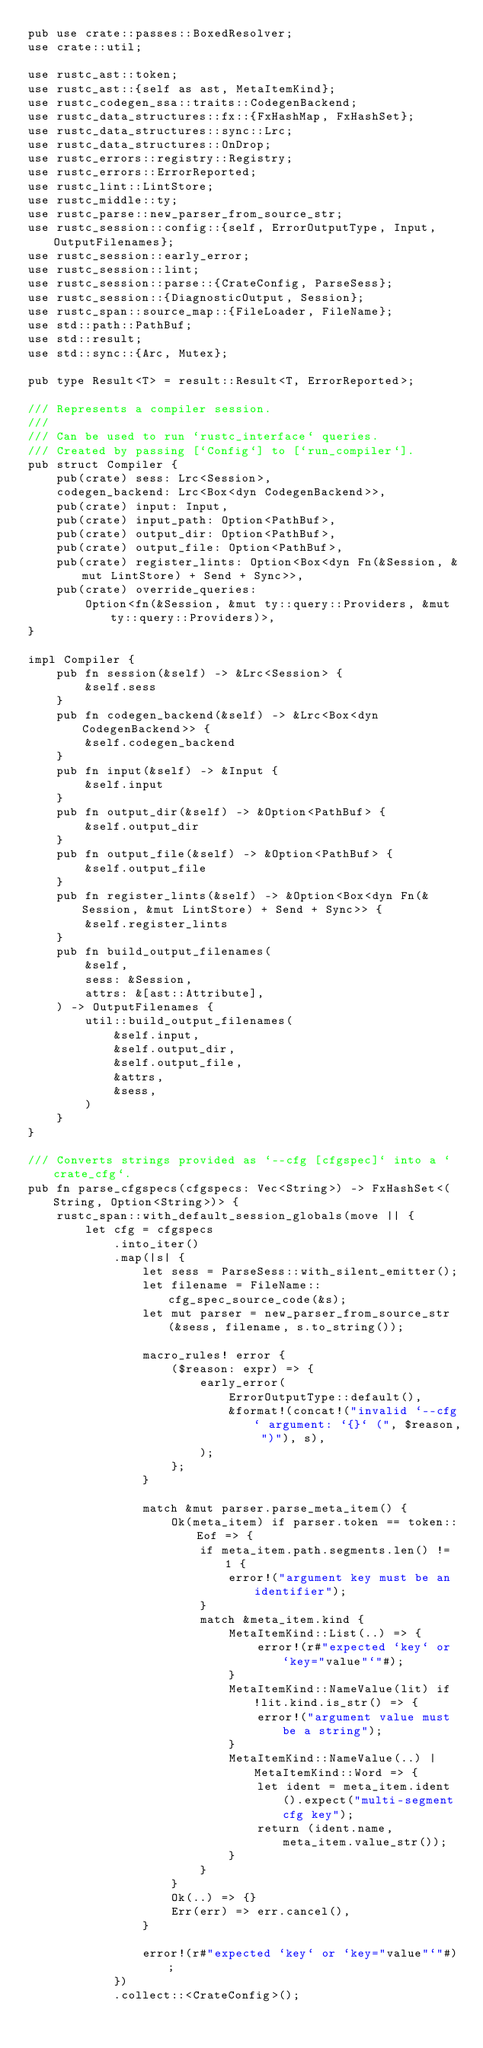Convert code to text. <code><loc_0><loc_0><loc_500><loc_500><_Rust_>pub use crate::passes::BoxedResolver;
use crate::util;

use rustc_ast::token;
use rustc_ast::{self as ast, MetaItemKind};
use rustc_codegen_ssa::traits::CodegenBackend;
use rustc_data_structures::fx::{FxHashMap, FxHashSet};
use rustc_data_structures::sync::Lrc;
use rustc_data_structures::OnDrop;
use rustc_errors::registry::Registry;
use rustc_errors::ErrorReported;
use rustc_lint::LintStore;
use rustc_middle::ty;
use rustc_parse::new_parser_from_source_str;
use rustc_session::config::{self, ErrorOutputType, Input, OutputFilenames};
use rustc_session::early_error;
use rustc_session::lint;
use rustc_session::parse::{CrateConfig, ParseSess};
use rustc_session::{DiagnosticOutput, Session};
use rustc_span::source_map::{FileLoader, FileName};
use std::path::PathBuf;
use std::result;
use std::sync::{Arc, Mutex};

pub type Result<T> = result::Result<T, ErrorReported>;

/// Represents a compiler session.
///
/// Can be used to run `rustc_interface` queries.
/// Created by passing [`Config`] to [`run_compiler`].
pub struct Compiler {
    pub(crate) sess: Lrc<Session>,
    codegen_backend: Lrc<Box<dyn CodegenBackend>>,
    pub(crate) input: Input,
    pub(crate) input_path: Option<PathBuf>,
    pub(crate) output_dir: Option<PathBuf>,
    pub(crate) output_file: Option<PathBuf>,
    pub(crate) register_lints: Option<Box<dyn Fn(&Session, &mut LintStore) + Send + Sync>>,
    pub(crate) override_queries:
        Option<fn(&Session, &mut ty::query::Providers, &mut ty::query::Providers)>,
}

impl Compiler {
    pub fn session(&self) -> &Lrc<Session> {
        &self.sess
    }
    pub fn codegen_backend(&self) -> &Lrc<Box<dyn CodegenBackend>> {
        &self.codegen_backend
    }
    pub fn input(&self) -> &Input {
        &self.input
    }
    pub fn output_dir(&self) -> &Option<PathBuf> {
        &self.output_dir
    }
    pub fn output_file(&self) -> &Option<PathBuf> {
        &self.output_file
    }
    pub fn register_lints(&self) -> &Option<Box<dyn Fn(&Session, &mut LintStore) + Send + Sync>> {
        &self.register_lints
    }
    pub fn build_output_filenames(
        &self,
        sess: &Session,
        attrs: &[ast::Attribute],
    ) -> OutputFilenames {
        util::build_output_filenames(
            &self.input,
            &self.output_dir,
            &self.output_file,
            &attrs,
            &sess,
        )
    }
}

/// Converts strings provided as `--cfg [cfgspec]` into a `crate_cfg`.
pub fn parse_cfgspecs(cfgspecs: Vec<String>) -> FxHashSet<(String, Option<String>)> {
    rustc_span::with_default_session_globals(move || {
        let cfg = cfgspecs
            .into_iter()
            .map(|s| {
                let sess = ParseSess::with_silent_emitter();
                let filename = FileName::cfg_spec_source_code(&s);
                let mut parser = new_parser_from_source_str(&sess, filename, s.to_string());

                macro_rules! error {
                    ($reason: expr) => {
                        early_error(
                            ErrorOutputType::default(),
                            &format!(concat!("invalid `--cfg` argument: `{}` (", $reason, ")"), s),
                        );
                    };
                }

                match &mut parser.parse_meta_item() {
                    Ok(meta_item) if parser.token == token::Eof => {
                        if meta_item.path.segments.len() != 1 {
                            error!("argument key must be an identifier");
                        }
                        match &meta_item.kind {
                            MetaItemKind::List(..) => {
                                error!(r#"expected `key` or `key="value"`"#);
                            }
                            MetaItemKind::NameValue(lit) if !lit.kind.is_str() => {
                                error!("argument value must be a string");
                            }
                            MetaItemKind::NameValue(..) | MetaItemKind::Word => {
                                let ident = meta_item.ident().expect("multi-segment cfg key");
                                return (ident.name, meta_item.value_str());
                            }
                        }
                    }
                    Ok(..) => {}
                    Err(err) => err.cancel(),
                }

                error!(r#"expected `key` or `key="value"`"#);
            })
            .collect::<CrateConfig>();</code> 